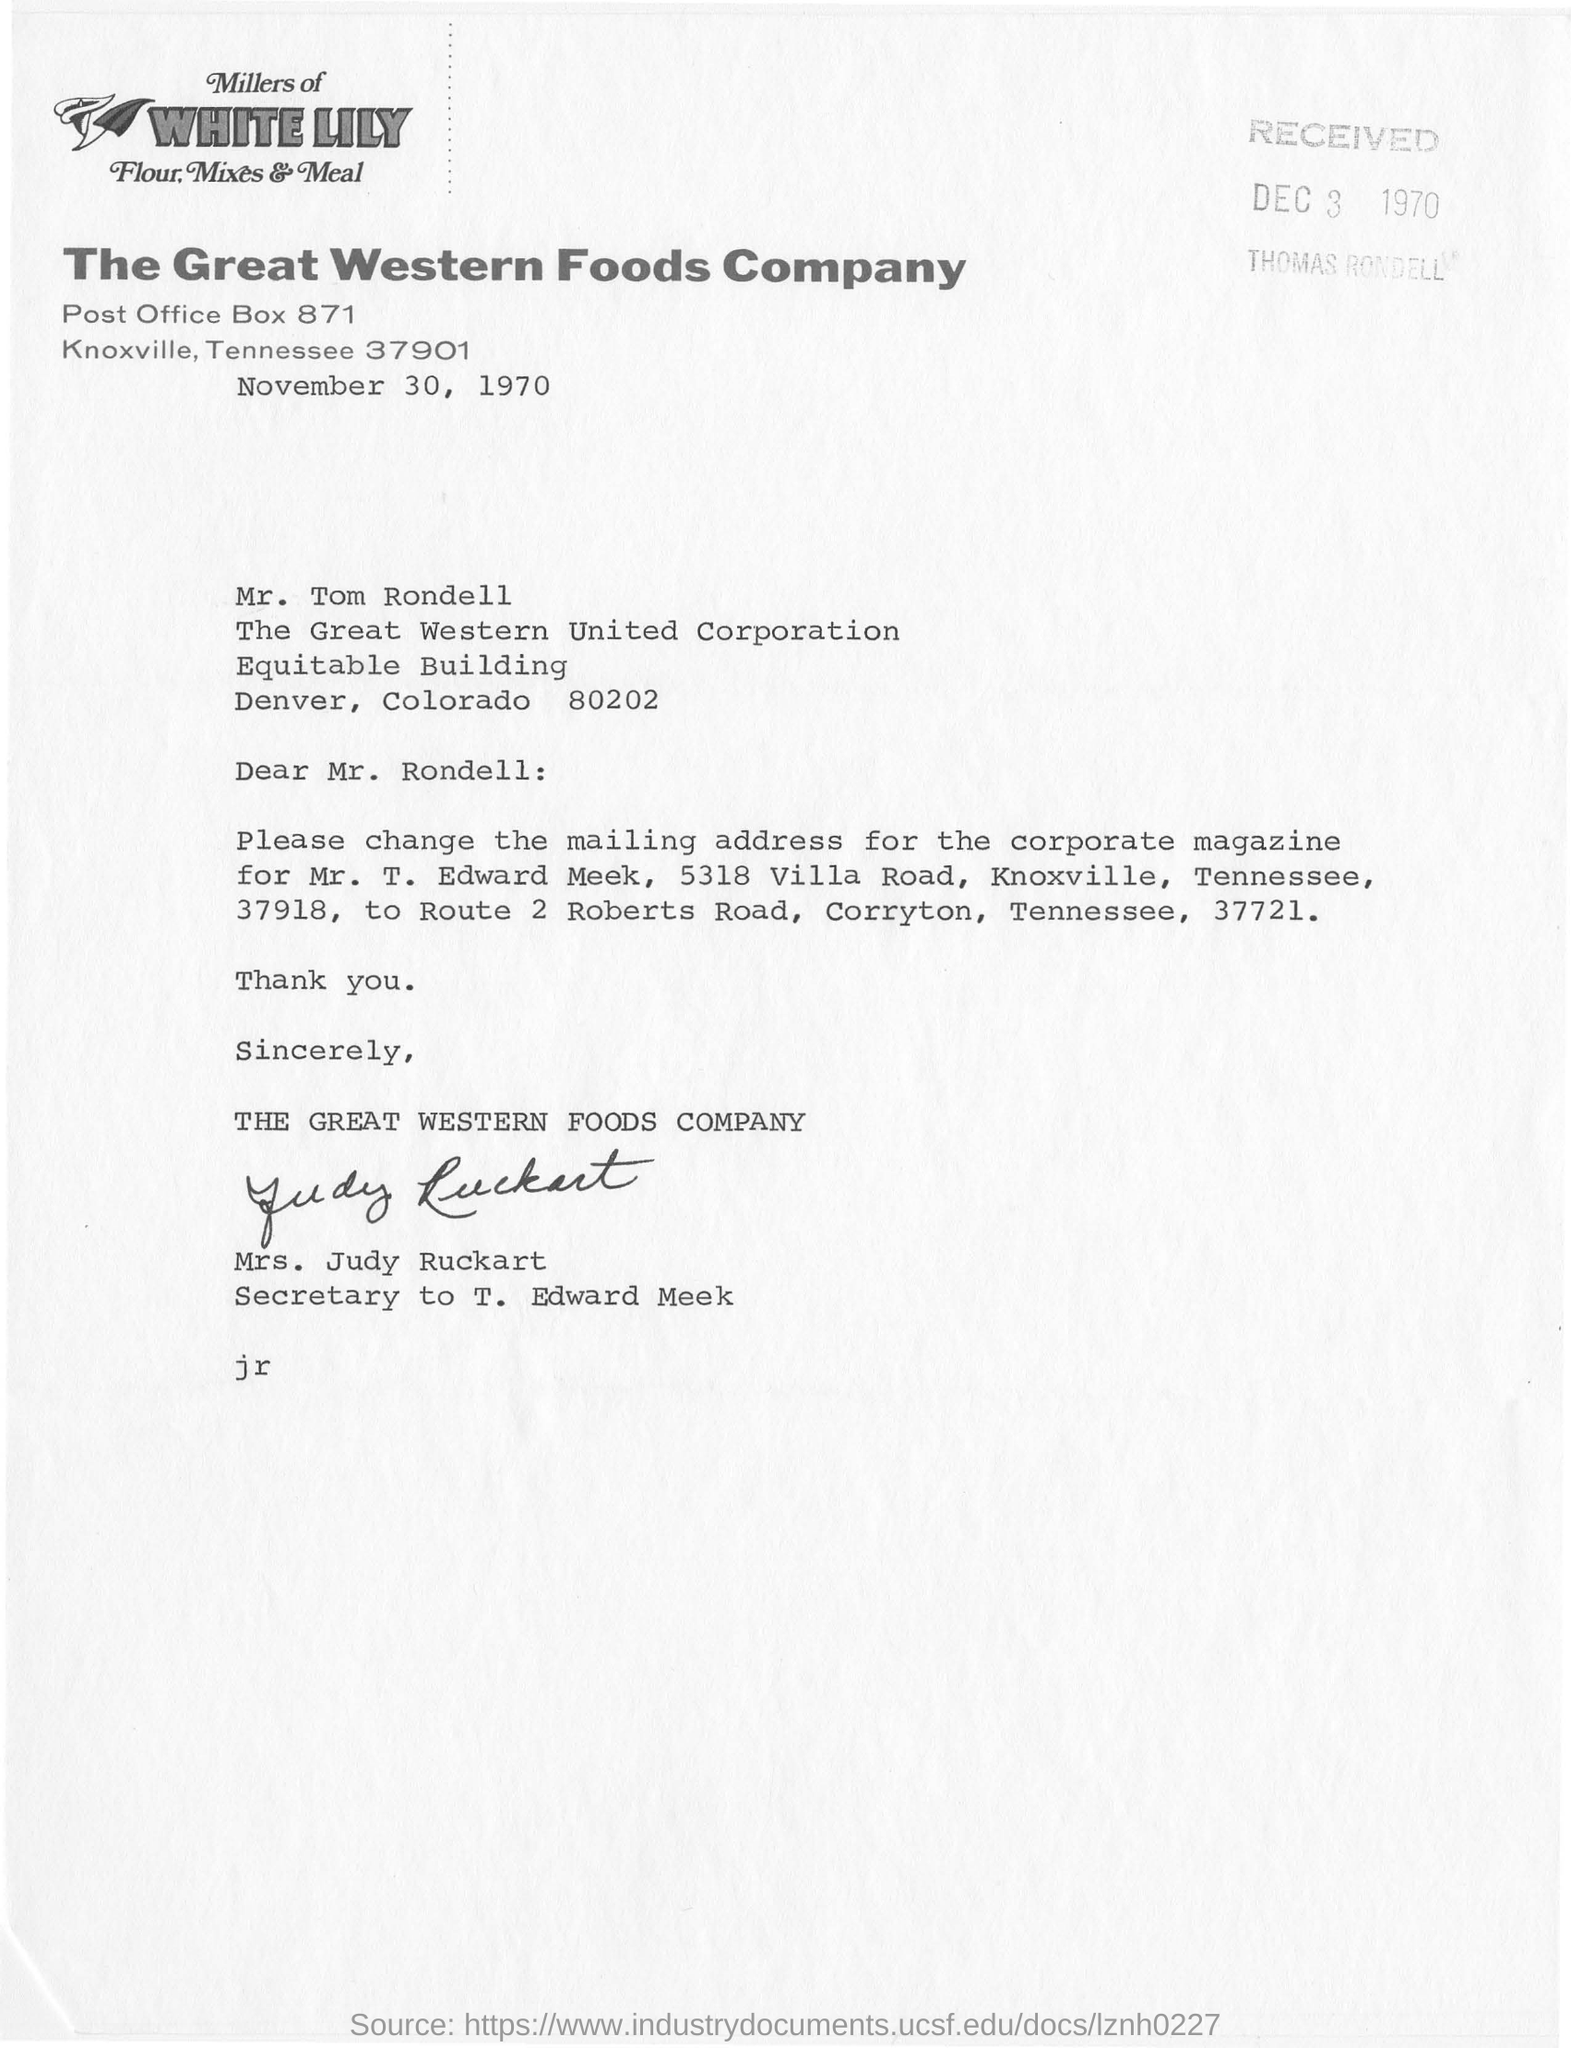Mention a couple of crucial points in this snapshot. The package was received on December 3, 1970. The company known as The Great Western Foods Company. 